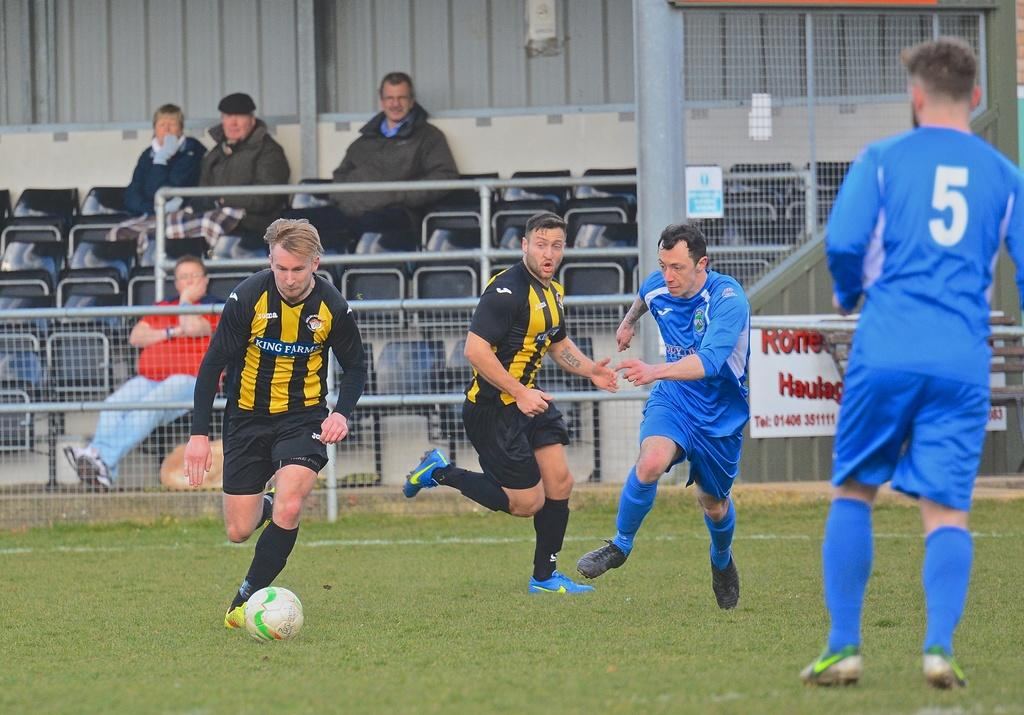<image>
Offer a succinct explanation of the picture presented. Player number 5 in blue watches as a player in yellow and black dribbles a soccer ball. 